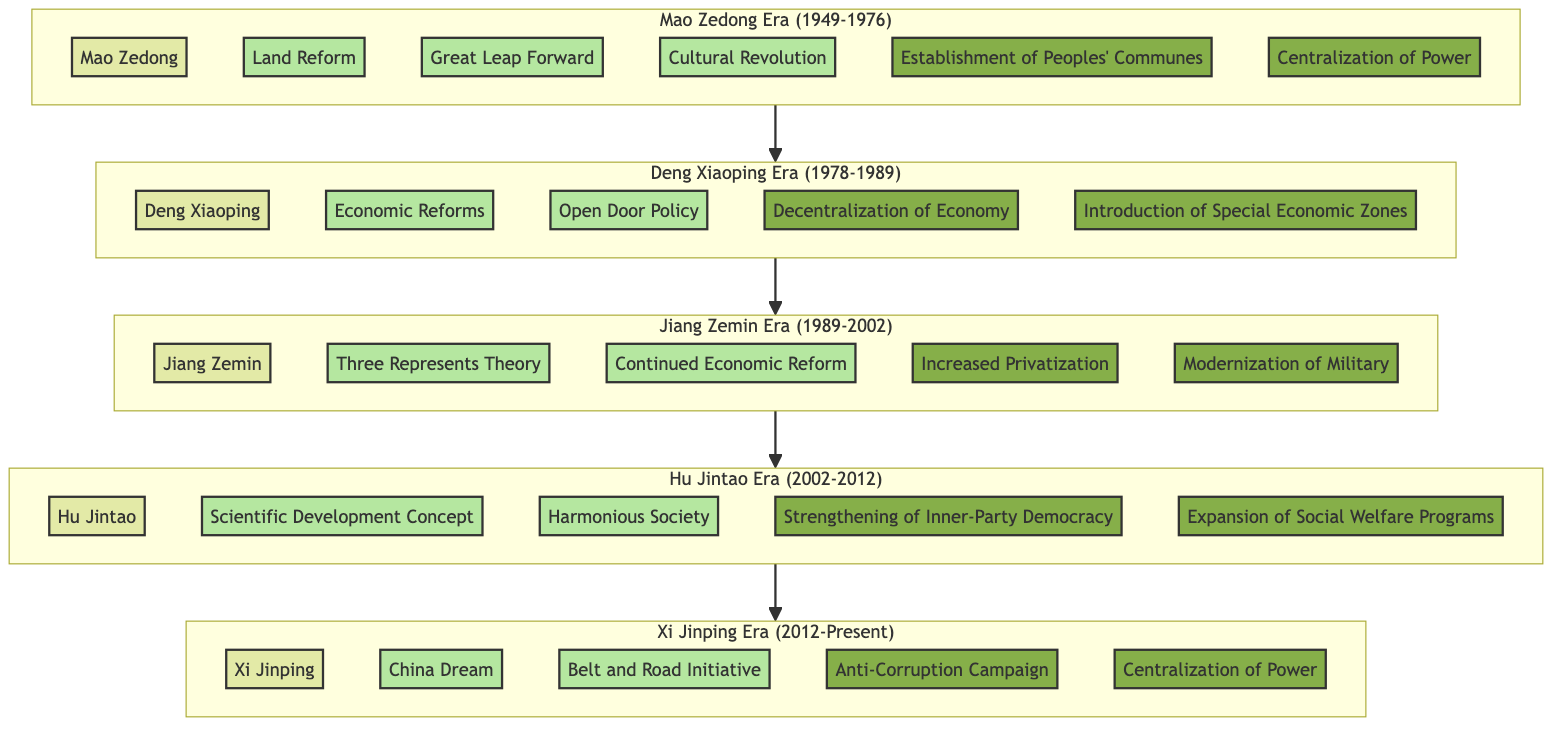What leadership era followed Mao Zedong? The diagram shows a sequence, where after the "Mao Zedong Era (1949-1976)" block, the next block is "Deng Xiaoping Era (1978-1989)". Hence, it indicates that Deng Xiaoping was the next leader.
Answer: Deng Xiaoping Era Which major policy is associated with Hu Jintao? By inspecting the "Hu Jintao Era (2002-2012)" block, we can see two major policies listed: "Scientific Development Concept" and "Harmonious Society". Both are directly associated with Hu Jintao.
Answer: Scientific Development Concept How many major policies were implemented during the Jiang Zemin Era? In the "Jiang Zemin Era (1989-2002)" block, there are two major policies mentioned: "Three Represents Theory" and "Continued Economic Reform". Therefore, the count of the major policies is derived directly from the block.
Answer: 2 What structural change was introduced during the Xi Jinping Era? Referring to the "Xi Jinping Era (2012-Present)" block, we find two structural changes: "Anti-Corruption Campaign" and "Centralization of Power". Hence, we can identify one specific structural change directly from this block.
Answer: Anti-Corruption Campaign Which leader's era was characterized by the establishment of Peoples' Communes? Looking at the "Mao Zedong Era (1949-1976)" block, we see that one of the structural changes listed is "Establishment of Peoples' Communes". This directly indicates that it was during Mao Zedong's leadership that this occurred.
Answer: Mao Zedong What transition happened between the Deng Xiaoping Era and Jiang Zemin Era? The diagram illustrates a flow from "Deng Xiaoping Era (1978-1989)" to "Jiang Zemin Era (1989-2002)", indicating a leadership transition. Hence, the transition is from Deng Xiaoping to Jiang Zemin.
Answer: Jiang Zemin How many total leadership eras are depicted in the diagram? By counting the blocks in the diagram, which correspond to different leadership eras, we find five distinct eras: Mao Zedong, Deng Xiaoping, Jiang Zemin, Hu Jintao, and Xi Jinping.
Answer: 5 What is a notable policy from the Xi Jinping Era? Within the "Xi Jinping Era (2012-Present)" block, two significant policies are listed: "China Dream" and "Belt and Road Initiative." From this, we can easily identify one key policy.
Answer: China Dream 